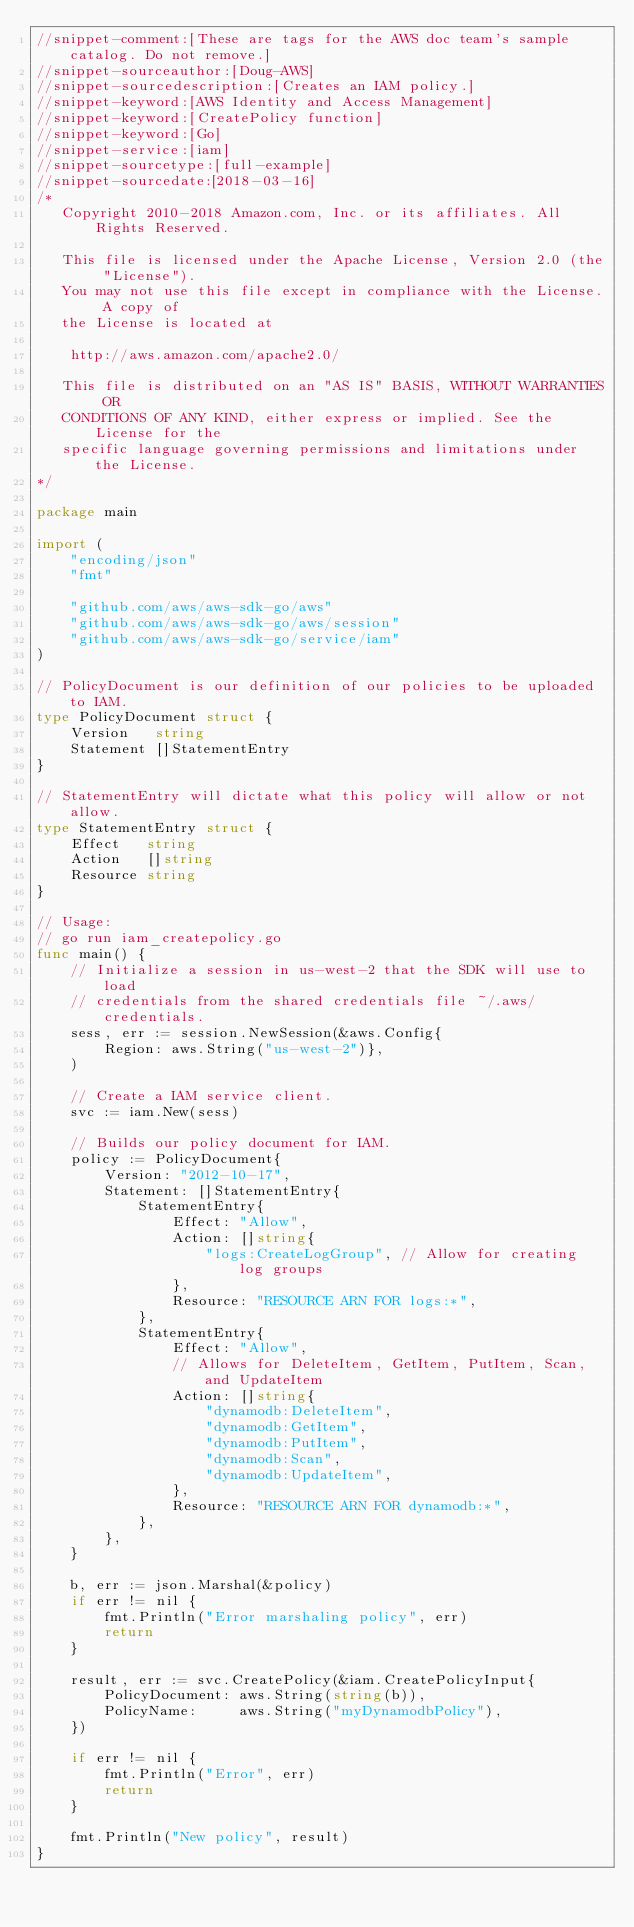Convert code to text. <code><loc_0><loc_0><loc_500><loc_500><_Go_>//snippet-comment:[These are tags for the AWS doc team's sample catalog. Do not remove.]
//snippet-sourceauthor:[Doug-AWS]
//snippet-sourcedescription:[Creates an IAM policy.]
//snippet-keyword:[AWS Identity and Access Management]
//snippet-keyword:[CreatePolicy function]
//snippet-keyword:[Go]
//snippet-service:[iam]
//snippet-sourcetype:[full-example]
//snippet-sourcedate:[2018-03-16]
/*
   Copyright 2010-2018 Amazon.com, Inc. or its affiliates. All Rights Reserved.

   This file is licensed under the Apache License, Version 2.0 (the "License").
   You may not use this file except in compliance with the License. A copy of
   the License is located at

    http://aws.amazon.com/apache2.0/

   This file is distributed on an "AS IS" BASIS, WITHOUT WARRANTIES OR
   CONDITIONS OF ANY KIND, either express or implied. See the License for the
   specific language governing permissions and limitations under the License.
*/

package main

import (
    "encoding/json"
    "fmt"

    "github.com/aws/aws-sdk-go/aws"
    "github.com/aws/aws-sdk-go/aws/session"
    "github.com/aws/aws-sdk-go/service/iam"
)

// PolicyDocument is our definition of our policies to be uploaded to IAM.
type PolicyDocument struct {
    Version   string
    Statement []StatementEntry
}

// StatementEntry will dictate what this policy will allow or not allow.
type StatementEntry struct {
    Effect   string
    Action   []string
    Resource string
}

// Usage:
// go run iam_createpolicy.go
func main() {
    // Initialize a session in us-west-2 that the SDK will use to load
    // credentials from the shared credentials file ~/.aws/credentials.
    sess, err := session.NewSession(&aws.Config{
        Region: aws.String("us-west-2")},
    )

    // Create a IAM service client.
    svc := iam.New(sess)

    // Builds our policy document for IAM.
    policy := PolicyDocument{
        Version: "2012-10-17",
        Statement: []StatementEntry{
            StatementEntry{
                Effect: "Allow",
                Action: []string{
                    "logs:CreateLogGroup", // Allow for creating log groups
                },
                Resource: "RESOURCE ARN FOR logs:*",
            },
            StatementEntry{
                Effect: "Allow",
                // Allows for DeleteItem, GetItem, PutItem, Scan, and UpdateItem
                Action: []string{
                    "dynamodb:DeleteItem",
                    "dynamodb:GetItem",
                    "dynamodb:PutItem",
                    "dynamodb:Scan",
                    "dynamodb:UpdateItem",
                },
                Resource: "RESOURCE ARN FOR dynamodb:*",
            },
        },
    }

    b, err := json.Marshal(&policy)
    if err != nil {
        fmt.Println("Error marshaling policy", err)
        return
    }

    result, err := svc.CreatePolicy(&iam.CreatePolicyInput{
        PolicyDocument: aws.String(string(b)),
        PolicyName:     aws.String("myDynamodbPolicy"),
    })

    if err != nil {
        fmt.Println("Error", err)
        return
    }

    fmt.Println("New policy", result)
}
</code> 